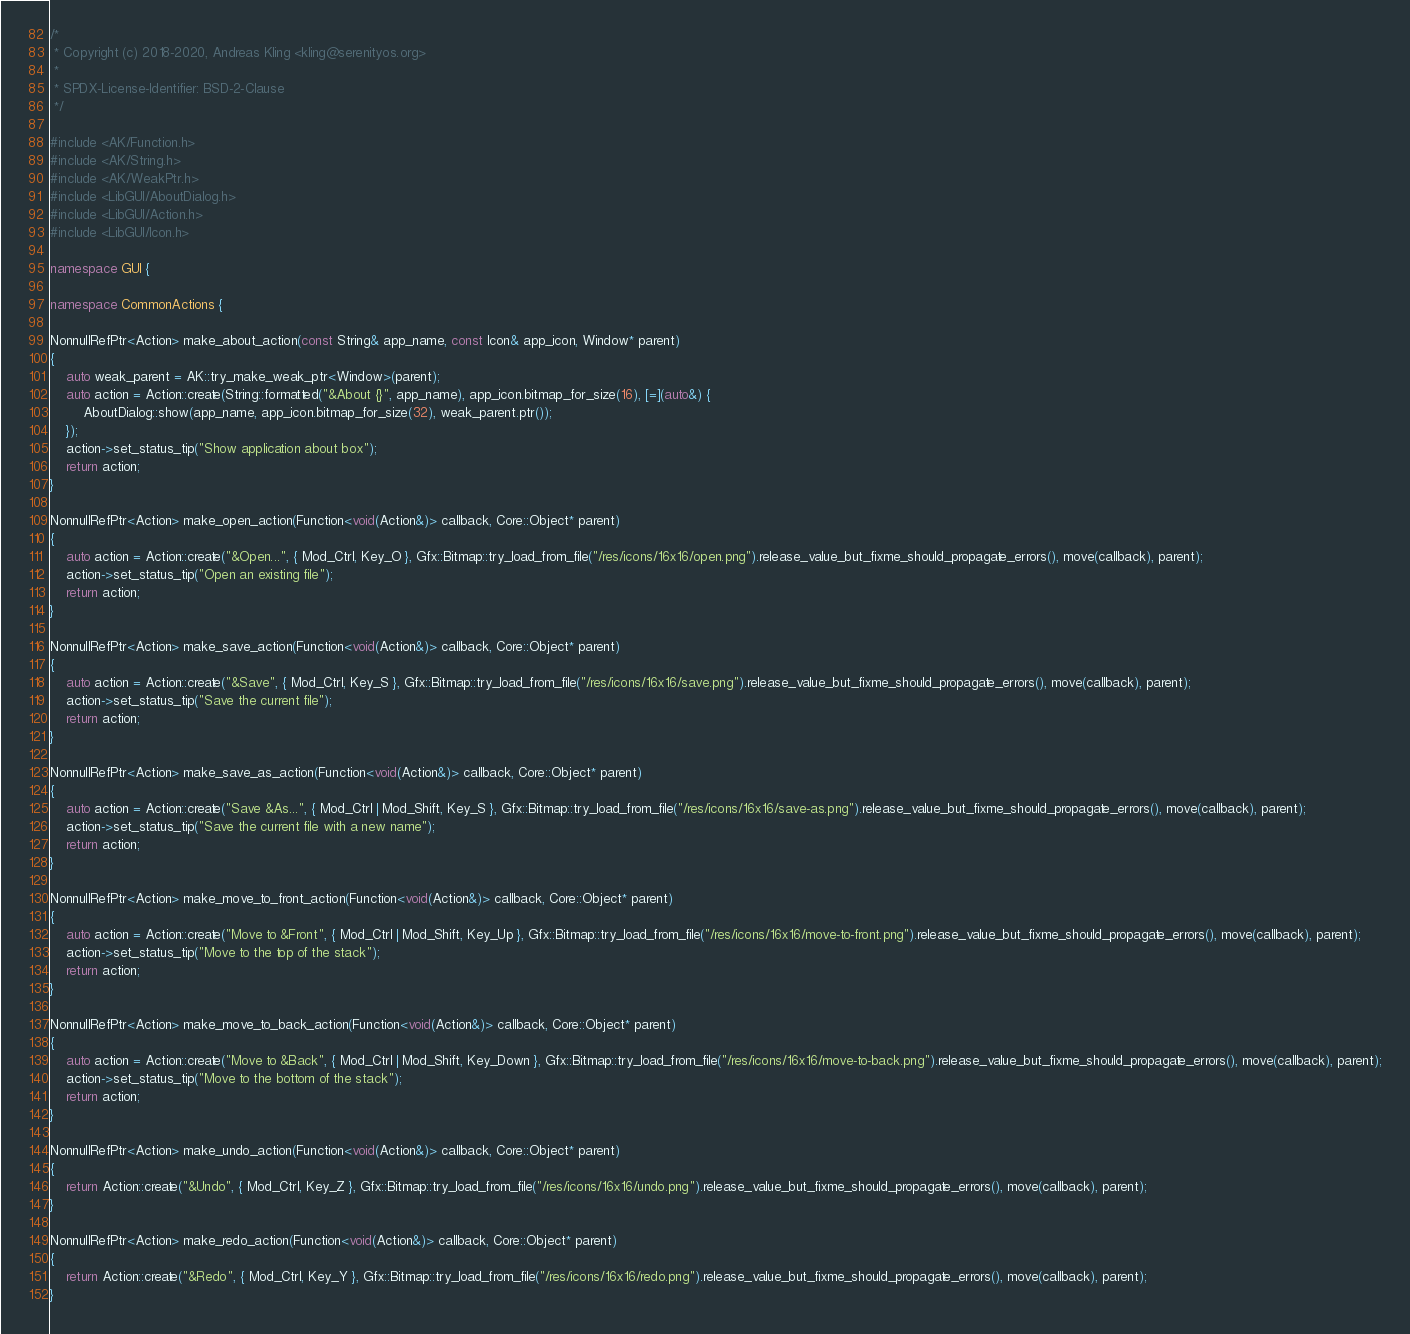<code> <loc_0><loc_0><loc_500><loc_500><_C++_>/*
 * Copyright (c) 2018-2020, Andreas Kling <kling@serenityos.org>
 *
 * SPDX-License-Identifier: BSD-2-Clause
 */

#include <AK/Function.h>
#include <AK/String.h>
#include <AK/WeakPtr.h>
#include <LibGUI/AboutDialog.h>
#include <LibGUI/Action.h>
#include <LibGUI/Icon.h>

namespace GUI {

namespace CommonActions {

NonnullRefPtr<Action> make_about_action(const String& app_name, const Icon& app_icon, Window* parent)
{
    auto weak_parent = AK::try_make_weak_ptr<Window>(parent);
    auto action = Action::create(String::formatted("&About {}", app_name), app_icon.bitmap_for_size(16), [=](auto&) {
        AboutDialog::show(app_name, app_icon.bitmap_for_size(32), weak_parent.ptr());
    });
    action->set_status_tip("Show application about box");
    return action;
}

NonnullRefPtr<Action> make_open_action(Function<void(Action&)> callback, Core::Object* parent)
{
    auto action = Action::create("&Open...", { Mod_Ctrl, Key_O }, Gfx::Bitmap::try_load_from_file("/res/icons/16x16/open.png").release_value_but_fixme_should_propagate_errors(), move(callback), parent);
    action->set_status_tip("Open an existing file");
    return action;
}

NonnullRefPtr<Action> make_save_action(Function<void(Action&)> callback, Core::Object* parent)
{
    auto action = Action::create("&Save", { Mod_Ctrl, Key_S }, Gfx::Bitmap::try_load_from_file("/res/icons/16x16/save.png").release_value_but_fixme_should_propagate_errors(), move(callback), parent);
    action->set_status_tip("Save the current file");
    return action;
}

NonnullRefPtr<Action> make_save_as_action(Function<void(Action&)> callback, Core::Object* parent)
{
    auto action = Action::create("Save &As...", { Mod_Ctrl | Mod_Shift, Key_S }, Gfx::Bitmap::try_load_from_file("/res/icons/16x16/save-as.png").release_value_but_fixme_should_propagate_errors(), move(callback), parent);
    action->set_status_tip("Save the current file with a new name");
    return action;
}

NonnullRefPtr<Action> make_move_to_front_action(Function<void(Action&)> callback, Core::Object* parent)
{
    auto action = Action::create("Move to &Front", { Mod_Ctrl | Mod_Shift, Key_Up }, Gfx::Bitmap::try_load_from_file("/res/icons/16x16/move-to-front.png").release_value_but_fixme_should_propagate_errors(), move(callback), parent);
    action->set_status_tip("Move to the top of the stack");
    return action;
}

NonnullRefPtr<Action> make_move_to_back_action(Function<void(Action&)> callback, Core::Object* parent)
{
    auto action = Action::create("Move to &Back", { Mod_Ctrl | Mod_Shift, Key_Down }, Gfx::Bitmap::try_load_from_file("/res/icons/16x16/move-to-back.png").release_value_but_fixme_should_propagate_errors(), move(callback), parent);
    action->set_status_tip("Move to the bottom of the stack");
    return action;
}

NonnullRefPtr<Action> make_undo_action(Function<void(Action&)> callback, Core::Object* parent)
{
    return Action::create("&Undo", { Mod_Ctrl, Key_Z }, Gfx::Bitmap::try_load_from_file("/res/icons/16x16/undo.png").release_value_but_fixme_should_propagate_errors(), move(callback), parent);
}

NonnullRefPtr<Action> make_redo_action(Function<void(Action&)> callback, Core::Object* parent)
{
    return Action::create("&Redo", { Mod_Ctrl, Key_Y }, Gfx::Bitmap::try_load_from_file("/res/icons/16x16/redo.png").release_value_but_fixme_should_propagate_errors(), move(callback), parent);
}
</code> 